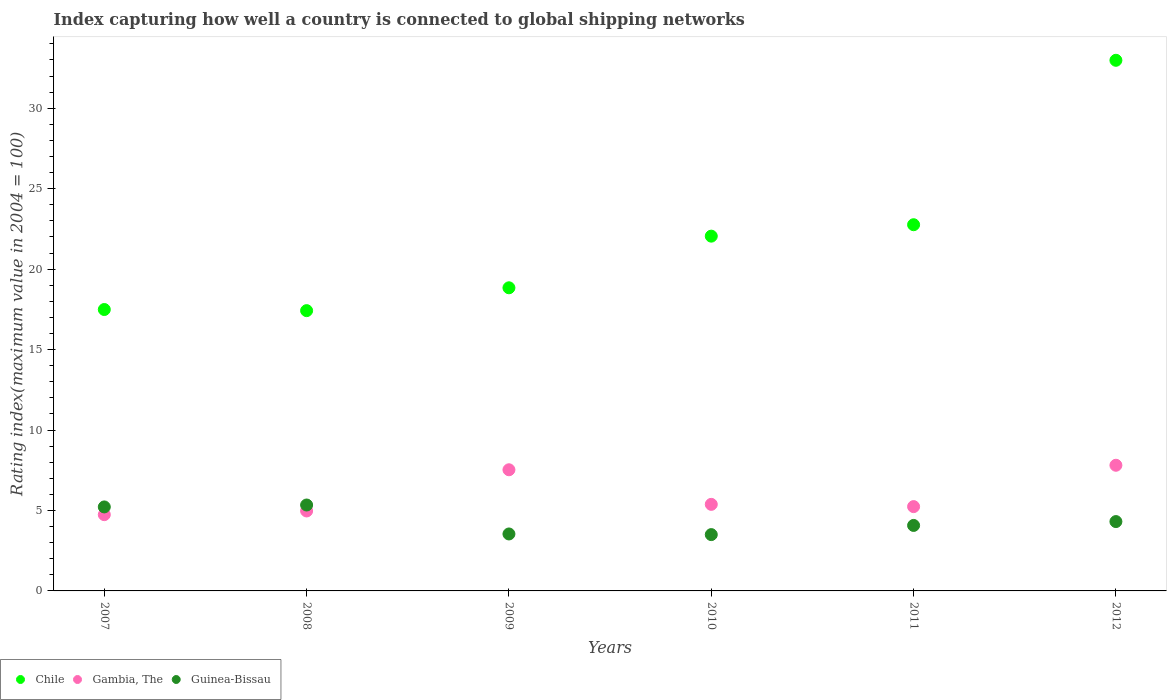Is the number of dotlines equal to the number of legend labels?
Your response must be concise. Yes. What is the rating index in Chile in 2007?
Offer a very short reply. 17.49. Across all years, what is the maximum rating index in Guinea-Bissau?
Your answer should be compact. 5.34. Across all years, what is the minimum rating index in Chile?
Offer a very short reply. 17.42. In which year was the rating index in Gambia, The minimum?
Your answer should be very brief. 2007. What is the total rating index in Chile in the graph?
Your answer should be compact. 131.54. What is the difference between the rating index in Guinea-Bissau in 2007 and that in 2011?
Offer a very short reply. 1.15. What is the difference between the rating index in Guinea-Bissau in 2011 and the rating index in Chile in 2009?
Make the answer very short. -14.77. What is the average rating index in Gambia, The per year?
Ensure brevity in your answer.  5.95. In the year 2009, what is the difference between the rating index in Guinea-Bissau and rating index in Chile?
Provide a short and direct response. -15.3. In how many years, is the rating index in Chile greater than 16?
Provide a succinct answer. 6. What is the ratio of the rating index in Gambia, The in 2008 to that in 2011?
Make the answer very short. 0.95. Is the rating index in Gambia, The in 2007 less than that in 2009?
Offer a terse response. Yes. Is the difference between the rating index in Guinea-Bissau in 2009 and 2010 greater than the difference between the rating index in Chile in 2009 and 2010?
Your answer should be very brief. Yes. What is the difference between the highest and the second highest rating index in Gambia, The?
Offer a terse response. 0.28. What is the difference between the highest and the lowest rating index in Chile?
Give a very brief answer. 15.56. Is the sum of the rating index in Chile in 2007 and 2008 greater than the maximum rating index in Guinea-Bissau across all years?
Provide a short and direct response. Yes. Does the rating index in Chile monotonically increase over the years?
Your answer should be very brief. No. Is the rating index in Gambia, The strictly greater than the rating index in Guinea-Bissau over the years?
Provide a succinct answer. No. What is the difference between two consecutive major ticks on the Y-axis?
Ensure brevity in your answer.  5. Are the values on the major ticks of Y-axis written in scientific E-notation?
Keep it short and to the point. No. Where does the legend appear in the graph?
Ensure brevity in your answer.  Bottom left. What is the title of the graph?
Your response must be concise. Index capturing how well a country is connected to global shipping networks. What is the label or title of the X-axis?
Your answer should be very brief. Years. What is the label or title of the Y-axis?
Provide a short and direct response. Rating index(maximum value in 2004 = 100). What is the Rating index(maximum value in 2004 = 100) of Chile in 2007?
Your response must be concise. 17.49. What is the Rating index(maximum value in 2004 = 100) in Gambia, The in 2007?
Keep it short and to the point. 4.74. What is the Rating index(maximum value in 2004 = 100) of Guinea-Bissau in 2007?
Provide a succinct answer. 5.22. What is the Rating index(maximum value in 2004 = 100) in Chile in 2008?
Your answer should be very brief. 17.42. What is the Rating index(maximum value in 2004 = 100) in Gambia, The in 2008?
Your answer should be compact. 4.97. What is the Rating index(maximum value in 2004 = 100) in Guinea-Bissau in 2008?
Offer a very short reply. 5.34. What is the Rating index(maximum value in 2004 = 100) of Chile in 2009?
Offer a very short reply. 18.84. What is the Rating index(maximum value in 2004 = 100) of Gambia, The in 2009?
Offer a very short reply. 7.53. What is the Rating index(maximum value in 2004 = 100) in Guinea-Bissau in 2009?
Make the answer very short. 3.54. What is the Rating index(maximum value in 2004 = 100) in Chile in 2010?
Your answer should be very brief. 22.05. What is the Rating index(maximum value in 2004 = 100) of Gambia, The in 2010?
Your response must be concise. 5.38. What is the Rating index(maximum value in 2004 = 100) of Guinea-Bissau in 2010?
Keep it short and to the point. 3.5. What is the Rating index(maximum value in 2004 = 100) in Chile in 2011?
Your answer should be compact. 22.76. What is the Rating index(maximum value in 2004 = 100) of Gambia, The in 2011?
Make the answer very short. 5.24. What is the Rating index(maximum value in 2004 = 100) of Guinea-Bissau in 2011?
Ensure brevity in your answer.  4.07. What is the Rating index(maximum value in 2004 = 100) of Chile in 2012?
Provide a short and direct response. 32.98. What is the Rating index(maximum value in 2004 = 100) in Gambia, The in 2012?
Keep it short and to the point. 7.81. What is the Rating index(maximum value in 2004 = 100) in Guinea-Bissau in 2012?
Offer a very short reply. 4.31. Across all years, what is the maximum Rating index(maximum value in 2004 = 100) of Chile?
Give a very brief answer. 32.98. Across all years, what is the maximum Rating index(maximum value in 2004 = 100) in Gambia, The?
Your answer should be very brief. 7.81. Across all years, what is the maximum Rating index(maximum value in 2004 = 100) of Guinea-Bissau?
Provide a short and direct response. 5.34. Across all years, what is the minimum Rating index(maximum value in 2004 = 100) in Chile?
Give a very brief answer. 17.42. Across all years, what is the minimum Rating index(maximum value in 2004 = 100) in Gambia, The?
Provide a short and direct response. 4.74. Across all years, what is the minimum Rating index(maximum value in 2004 = 100) of Guinea-Bissau?
Give a very brief answer. 3.5. What is the total Rating index(maximum value in 2004 = 100) of Chile in the graph?
Your answer should be compact. 131.54. What is the total Rating index(maximum value in 2004 = 100) of Gambia, The in the graph?
Ensure brevity in your answer.  35.67. What is the total Rating index(maximum value in 2004 = 100) in Guinea-Bissau in the graph?
Ensure brevity in your answer.  25.98. What is the difference between the Rating index(maximum value in 2004 = 100) in Chile in 2007 and that in 2008?
Your response must be concise. 0.07. What is the difference between the Rating index(maximum value in 2004 = 100) of Gambia, The in 2007 and that in 2008?
Keep it short and to the point. -0.23. What is the difference between the Rating index(maximum value in 2004 = 100) of Guinea-Bissau in 2007 and that in 2008?
Offer a terse response. -0.12. What is the difference between the Rating index(maximum value in 2004 = 100) of Chile in 2007 and that in 2009?
Provide a succinct answer. -1.35. What is the difference between the Rating index(maximum value in 2004 = 100) in Gambia, The in 2007 and that in 2009?
Offer a very short reply. -2.79. What is the difference between the Rating index(maximum value in 2004 = 100) in Guinea-Bissau in 2007 and that in 2009?
Offer a very short reply. 1.68. What is the difference between the Rating index(maximum value in 2004 = 100) in Chile in 2007 and that in 2010?
Your answer should be compact. -4.56. What is the difference between the Rating index(maximum value in 2004 = 100) in Gambia, The in 2007 and that in 2010?
Keep it short and to the point. -0.64. What is the difference between the Rating index(maximum value in 2004 = 100) in Guinea-Bissau in 2007 and that in 2010?
Your response must be concise. 1.72. What is the difference between the Rating index(maximum value in 2004 = 100) of Chile in 2007 and that in 2011?
Your answer should be very brief. -5.27. What is the difference between the Rating index(maximum value in 2004 = 100) in Guinea-Bissau in 2007 and that in 2011?
Provide a short and direct response. 1.15. What is the difference between the Rating index(maximum value in 2004 = 100) of Chile in 2007 and that in 2012?
Give a very brief answer. -15.49. What is the difference between the Rating index(maximum value in 2004 = 100) of Gambia, The in 2007 and that in 2012?
Offer a terse response. -3.07. What is the difference between the Rating index(maximum value in 2004 = 100) in Guinea-Bissau in 2007 and that in 2012?
Provide a short and direct response. 0.91. What is the difference between the Rating index(maximum value in 2004 = 100) of Chile in 2008 and that in 2009?
Your answer should be compact. -1.42. What is the difference between the Rating index(maximum value in 2004 = 100) of Gambia, The in 2008 and that in 2009?
Your answer should be compact. -2.56. What is the difference between the Rating index(maximum value in 2004 = 100) in Guinea-Bissau in 2008 and that in 2009?
Offer a very short reply. 1.8. What is the difference between the Rating index(maximum value in 2004 = 100) in Chile in 2008 and that in 2010?
Ensure brevity in your answer.  -4.63. What is the difference between the Rating index(maximum value in 2004 = 100) of Gambia, The in 2008 and that in 2010?
Your answer should be compact. -0.41. What is the difference between the Rating index(maximum value in 2004 = 100) of Guinea-Bissau in 2008 and that in 2010?
Keep it short and to the point. 1.84. What is the difference between the Rating index(maximum value in 2004 = 100) of Chile in 2008 and that in 2011?
Offer a very short reply. -5.34. What is the difference between the Rating index(maximum value in 2004 = 100) of Gambia, The in 2008 and that in 2011?
Offer a terse response. -0.27. What is the difference between the Rating index(maximum value in 2004 = 100) of Guinea-Bissau in 2008 and that in 2011?
Provide a short and direct response. 1.27. What is the difference between the Rating index(maximum value in 2004 = 100) in Chile in 2008 and that in 2012?
Provide a succinct answer. -15.56. What is the difference between the Rating index(maximum value in 2004 = 100) in Gambia, The in 2008 and that in 2012?
Give a very brief answer. -2.84. What is the difference between the Rating index(maximum value in 2004 = 100) in Guinea-Bissau in 2008 and that in 2012?
Your answer should be compact. 1.03. What is the difference between the Rating index(maximum value in 2004 = 100) of Chile in 2009 and that in 2010?
Give a very brief answer. -3.21. What is the difference between the Rating index(maximum value in 2004 = 100) of Gambia, The in 2009 and that in 2010?
Your answer should be compact. 2.15. What is the difference between the Rating index(maximum value in 2004 = 100) of Chile in 2009 and that in 2011?
Your response must be concise. -3.92. What is the difference between the Rating index(maximum value in 2004 = 100) of Gambia, The in 2009 and that in 2011?
Keep it short and to the point. 2.29. What is the difference between the Rating index(maximum value in 2004 = 100) in Guinea-Bissau in 2009 and that in 2011?
Keep it short and to the point. -0.53. What is the difference between the Rating index(maximum value in 2004 = 100) in Chile in 2009 and that in 2012?
Give a very brief answer. -14.14. What is the difference between the Rating index(maximum value in 2004 = 100) in Gambia, The in 2009 and that in 2012?
Offer a very short reply. -0.28. What is the difference between the Rating index(maximum value in 2004 = 100) in Guinea-Bissau in 2009 and that in 2012?
Give a very brief answer. -0.77. What is the difference between the Rating index(maximum value in 2004 = 100) of Chile in 2010 and that in 2011?
Your response must be concise. -0.71. What is the difference between the Rating index(maximum value in 2004 = 100) in Gambia, The in 2010 and that in 2011?
Your response must be concise. 0.14. What is the difference between the Rating index(maximum value in 2004 = 100) of Guinea-Bissau in 2010 and that in 2011?
Offer a very short reply. -0.57. What is the difference between the Rating index(maximum value in 2004 = 100) in Chile in 2010 and that in 2012?
Offer a very short reply. -10.93. What is the difference between the Rating index(maximum value in 2004 = 100) in Gambia, The in 2010 and that in 2012?
Your answer should be compact. -2.43. What is the difference between the Rating index(maximum value in 2004 = 100) of Guinea-Bissau in 2010 and that in 2012?
Your answer should be very brief. -0.81. What is the difference between the Rating index(maximum value in 2004 = 100) of Chile in 2011 and that in 2012?
Keep it short and to the point. -10.22. What is the difference between the Rating index(maximum value in 2004 = 100) of Gambia, The in 2011 and that in 2012?
Offer a very short reply. -2.57. What is the difference between the Rating index(maximum value in 2004 = 100) of Guinea-Bissau in 2011 and that in 2012?
Offer a very short reply. -0.24. What is the difference between the Rating index(maximum value in 2004 = 100) in Chile in 2007 and the Rating index(maximum value in 2004 = 100) in Gambia, The in 2008?
Ensure brevity in your answer.  12.52. What is the difference between the Rating index(maximum value in 2004 = 100) of Chile in 2007 and the Rating index(maximum value in 2004 = 100) of Guinea-Bissau in 2008?
Your answer should be very brief. 12.15. What is the difference between the Rating index(maximum value in 2004 = 100) of Chile in 2007 and the Rating index(maximum value in 2004 = 100) of Gambia, The in 2009?
Offer a very short reply. 9.96. What is the difference between the Rating index(maximum value in 2004 = 100) in Chile in 2007 and the Rating index(maximum value in 2004 = 100) in Guinea-Bissau in 2009?
Offer a very short reply. 13.95. What is the difference between the Rating index(maximum value in 2004 = 100) in Gambia, The in 2007 and the Rating index(maximum value in 2004 = 100) in Guinea-Bissau in 2009?
Offer a terse response. 1.2. What is the difference between the Rating index(maximum value in 2004 = 100) of Chile in 2007 and the Rating index(maximum value in 2004 = 100) of Gambia, The in 2010?
Keep it short and to the point. 12.11. What is the difference between the Rating index(maximum value in 2004 = 100) of Chile in 2007 and the Rating index(maximum value in 2004 = 100) of Guinea-Bissau in 2010?
Give a very brief answer. 13.99. What is the difference between the Rating index(maximum value in 2004 = 100) of Gambia, The in 2007 and the Rating index(maximum value in 2004 = 100) of Guinea-Bissau in 2010?
Your response must be concise. 1.24. What is the difference between the Rating index(maximum value in 2004 = 100) of Chile in 2007 and the Rating index(maximum value in 2004 = 100) of Gambia, The in 2011?
Ensure brevity in your answer.  12.25. What is the difference between the Rating index(maximum value in 2004 = 100) in Chile in 2007 and the Rating index(maximum value in 2004 = 100) in Guinea-Bissau in 2011?
Offer a very short reply. 13.42. What is the difference between the Rating index(maximum value in 2004 = 100) of Gambia, The in 2007 and the Rating index(maximum value in 2004 = 100) of Guinea-Bissau in 2011?
Give a very brief answer. 0.67. What is the difference between the Rating index(maximum value in 2004 = 100) in Chile in 2007 and the Rating index(maximum value in 2004 = 100) in Gambia, The in 2012?
Provide a succinct answer. 9.68. What is the difference between the Rating index(maximum value in 2004 = 100) in Chile in 2007 and the Rating index(maximum value in 2004 = 100) in Guinea-Bissau in 2012?
Your response must be concise. 13.18. What is the difference between the Rating index(maximum value in 2004 = 100) of Gambia, The in 2007 and the Rating index(maximum value in 2004 = 100) of Guinea-Bissau in 2012?
Offer a very short reply. 0.43. What is the difference between the Rating index(maximum value in 2004 = 100) in Chile in 2008 and the Rating index(maximum value in 2004 = 100) in Gambia, The in 2009?
Ensure brevity in your answer.  9.89. What is the difference between the Rating index(maximum value in 2004 = 100) of Chile in 2008 and the Rating index(maximum value in 2004 = 100) of Guinea-Bissau in 2009?
Provide a short and direct response. 13.88. What is the difference between the Rating index(maximum value in 2004 = 100) in Gambia, The in 2008 and the Rating index(maximum value in 2004 = 100) in Guinea-Bissau in 2009?
Provide a succinct answer. 1.43. What is the difference between the Rating index(maximum value in 2004 = 100) in Chile in 2008 and the Rating index(maximum value in 2004 = 100) in Gambia, The in 2010?
Keep it short and to the point. 12.04. What is the difference between the Rating index(maximum value in 2004 = 100) of Chile in 2008 and the Rating index(maximum value in 2004 = 100) of Guinea-Bissau in 2010?
Make the answer very short. 13.92. What is the difference between the Rating index(maximum value in 2004 = 100) of Gambia, The in 2008 and the Rating index(maximum value in 2004 = 100) of Guinea-Bissau in 2010?
Make the answer very short. 1.47. What is the difference between the Rating index(maximum value in 2004 = 100) of Chile in 2008 and the Rating index(maximum value in 2004 = 100) of Gambia, The in 2011?
Offer a very short reply. 12.18. What is the difference between the Rating index(maximum value in 2004 = 100) of Chile in 2008 and the Rating index(maximum value in 2004 = 100) of Guinea-Bissau in 2011?
Your response must be concise. 13.35. What is the difference between the Rating index(maximum value in 2004 = 100) of Gambia, The in 2008 and the Rating index(maximum value in 2004 = 100) of Guinea-Bissau in 2011?
Give a very brief answer. 0.9. What is the difference between the Rating index(maximum value in 2004 = 100) in Chile in 2008 and the Rating index(maximum value in 2004 = 100) in Gambia, The in 2012?
Offer a terse response. 9.61. What is the difference between the Rating index(maximum value in 2004 = 100) in Chile in 2008 and the Rating index(maximum value in 2004 = 100) in Guinea-Bissau in 2012?
Your answer should be compact. 13.11. What is the difference between the Rating index(maximum value in 2004 = 100) of Gambia, The in 2008 and the Rating index(maximum value in 2004 = 100) of Guinea-Bissau in 2012?
Your response must be concise. 0.66. What is the difference between the Rating index(maximum value in 2004 = 100) in Chile in 2009 and the Rating index(maximum value in 2004 = 100) in Gambia, The in 2010?
Make the answer very short. 13.46. What is the difference between the Rating index(maximum value in 2004 = 100) of Chile in 2009 and the Rating index(maximum value in 2004 = 100) of Guinea-Bissau in 2010?
Your response must be concise. 15.34. What is the difference between the Rating index(maximum value in 2004 = 100) of Gambia, The in 2009 and the Rating index(maximum value in 2004 = 100) of Guinea-Bissau in 2010?
Offer a terse response. 4.03. What is the difference between the Rating index(maximum value in 2004 = 100) of Chile in 2009 and the Rating index(maximum value in 2004 = 100) of Guinea-Bissau in 2011?
Your answer should be compact. 14.77. What is the difference between the Rating index(maximum value in 2004 = 100) in Gambia, The in 2009 and the Rating index(maximum value in 2004 = 100) in Guinea-Bissau in 2011?
Provide a succinct answer. 3.46. What is the difference between the Rating index(maximum value in 2004 = 100) of Chile in 2009 and the Rating index(maximum value in 2004 = 100) of Gambia, The in 2012?
Your answer should be very brief. 11.03. What is the difference between the Rating index(maximum value in 2004 = 100) in Chile in 2009 and the Rating index(maximum value in 2004 = 100) in Guinea-Bissau in 2012?
Make the answer very short. 14.53. What is the difference between the Rating index(maximum value in 2004 = 100) in Gambia, The in 2009 and the Rating index(maximum value in 2004 = 100) in Guinea-Bissau in 2012?
Make the answer very short. 3.22. What is the difference between the Rating index(maximum value in 2004 = 100) in Chile in 2010 and the Rating index(maximum value in 2004 = 100) in Gambia, The in 2011?
Keep it short and to the point. 16.81. What is the difference between the Rating index(maximum value in 2004 = 100) in Chile in 2010 and the Rating index(maximum value in 2004 = 100) in Guinea-Bissau in 2011?
Provide a succinct answer. 17.98. What is the difference between the Rating index(maximum value in 2004 = 100) of Gambia, The in 2010 and the Rating index(maximum value in 2004 = 100) of Guinea-Bissau in 2011?
Give a very brief answer. 1.31. What is the difference between the Rating index(maximum value in 2004 = 100) in Chile in 2010 and the Rating index(maximum value in 2004 = 100) in Gambia, The in 2012?
Make the answer very short. 14.24. What is the difference between the Rating index(maximum value in 2004 = 100) in Chile in 2010 and the Rating index(maximum value in 2004 = 100) in Guinea-Bissau in 2012?
Your response must be concise. 17.74. What is the difference between the Rating index(maximum value in 2004 = 100) in Gambia, The in 2010 and the Rating index(maximum value in 2004 = 100) in Guinea-Bissau in 2012?
Make the answer very short. 1.07. What is the difference between the Rating index(maximum value in 2004 = 100) in Chile in 2011 and the Rating index(maximum value in 2004 = 100) in Gambia, The in 2012?
Give a very brief answer. 14.95. What is the difference between the Rating index(maximum value in 2004 = 100) of Chile in 2011 and the Rating index(maximum value in 2004 = 100) of Guinea-Bissau in 2012?
Keep it short and to the point. 18.45. What is the difference between the Rating index(maximum value in 2004 = 100) in Gambia, The in 2011 and the Rating index(maximum value in 2004 = 100) in Guinea-Bissau in 2012?
Your response must be concise. 0.93. What is the average Rating index(maximum value in 2004 = 100) of Chile per year?
Your response must be concise. 21.92. What is the average Rating index(maximum value in 2004 = 100) in Gambia, The per year?
Your response must be concise. 5.95. What is the average Rating index(maximum value in 2004 = 100) in Guinea-Bissau per year?
Offer a very short reply. 4.33. In the year 2007, what is the difference between the Rating index(maximum value in 2004 = 100) of Chile and Rating index(maximum value in 2004 = 100) of Gambia, The?
Your answer should be compact. 12.75. In the year 2007, what is the difference between the Rating index(maximum value in 2004 = 100) in Chile and Rating index(maximum value in 2004 = 100) in Guinea-Bissau?
Offer a very short reply. 12.27. In the year 2007, what is the difference between the Rating index(maximum value in 2004 = 100) in Gambia, The and Rating index(maximum value in 2004 = 100) in Guinea-Bissau?
Your answer should be very brief. -0.48. In the year 2008, what is the difference between the Rating index(maximum value in 2004 = 100) in Chile and Rating index(maximum value in 2004 = 100) in Gambia, The?
Your answer should be very brief. 12.45. In the year 2008, what is the difference between the Rating index(maximum value in 2004 = 100) in Chile and Rating index(maximum value in 2004 = 100) in Guinea-Bissau?
Give a very brief answer. 12.08. In the year 2008, what is the difference between the Rating index(maximum value in 2004 = 100) in Gambia, The and Rating index(maximum value in 2004 = 100) in Guinea-Bissau?
Your response must be concise. -0.37. In the year 2009, what is the difference between the Rating index(maximum value in 2004 = 100) in Chile and Rating index(maximum value in 2004 = 100) in Gambia, The?
Give a very brief answer. 11.31. In the year 2009, what is the difference between the Rating index(maximum value in 2004 = 100) of Gambia, The and Rating index(maximum value in 2004 = 100) of Guinea-Bissau?
Your answer should be compact. 3.99. In the year 2010, what is the difference between the Rating index(maximum value in 2004 = 100) of Chile and Rating index(maximum value in 2004 = 100) of Gambia, The?
Make the answer very short. 16.67. In the year 2010, what is the difference between the Rating index(maximum value in 2004 = 100) of Chile and Rating index(maximum value in 2004 = 100) of Guinea-Bissau?
Offer a very short reply. 18.55. In the year 2010, what is the difference between the Rating index(maximum value in 2004 = 100) of Gambia, The and Rating index(maximum value in 2004 = 100) of Guinea-Bissau?
Give a very brief answer. 1.88. In the year 2011, what is the difference between the Rating index(maximum value in 2004 = 100) in Chile and Rating index(maximum value in 2004 = 100) in Gambia, The?
Offer a terse response. 17.52. In the year 2011, what is the difference between the Rating index(maximum value in 2004 = 100) in Chile and Rating index(maximum value in 2004 = 100) in Guinea-Bissau?
Your answer should be very brief. 18.69. In the year 2011, what is the difference between the Rating index(maximum value in 2004 = 100) in Gambia, The and Rating index(maximum value in 2004 = 100) in Guinea-Bissau?
Ensure brevity in your answer.  1.17. In the year 2012, what is the difference between the Rating index(maximum value in 2004 = 100) in Chile and Rating index(maximum value in 2004 = 100) in Gambia, The?
Give a very brief answer. 25.17. In the year 2012, what is the difference between the Rating index(maximum value in 2004 = 100) in Chile and Rating index(maximum value in 2004 = 100) in Guinea-Bissau?
Make the answer very short. 28.67. What is the ratio of the Rating index(maximum value in 2004 = 100) of Gambia, The in 2007 to that in 2008?
Offer a very short reply. 0.95. What is the ratio of the Rating index(maximum value in 2004 = 100) of Guinea-Bissau in 2007 to that in 2008?
Make the answer very short. 0.98. What is the ratio of the Rating index(maximum value in 2004 = 100) of Chile in 2007 to that in 2009?
Offer a very short reply. 0.93. What is the ratio of the Rating index(maximum value in 2004 = 100) in Gambia, The in 2007 to that in 2009?
Provide a succinct answer. 0.63. What is the ratio of the Rating index(maximum value in 2004 = 100) in Guinea-Bissau in 2007 to that in 2009?
Give a very brief answer. 1.47. What is the ratio of the Rating index(maximum value in 2004 = 100) in Chile in 2007 to that in 2010?
Ensure brevity in your answer.  0.79. What is the ratio of the Rating index(maximum value in 2004 = 100) in Gambia, The in 2007 to that in 2010?
Give a very brief answer. 0.88. What is the ratio of the Rating index(maximum value in 2004 = 100) of Guinea-Bissau in 2007 to that in 2010?
Offer a terse response. 1.49. What is the ratio of the Rating index(maximum value in 2004 = 100) of Chile in 2007 to that in 2011?
Provide a succinct answer. 0.77. What is the ratio of the Rating index(maximum value in 2004 = 100) in Gambia, The in 2007 to that in 2011?
Give a very brief answer. 0.9. What is the ratio of the Rating index(maximum value in 2004 = 100) of Guinea-Bissau in 2007 to that in 2011?
Your answer should be compact. 1.28. What is the ratio of the Rating index(maximum value in 2004 = 100) of Chile in 2007 to that in 2012?
Offer a very short reply. 0.53. What is the ratio of the Rating index(maximum value in 2004 = 100) of Gambia, The in 2007 to that in 2012?
Provide a succinct answer. 0.61. What is the ratio of the Rating index(maximum value in 2004 = 100) in Guinea-Bissau in 2007 to that in 2012?
Your answer should be compact. 1.21. What is the ratio of the Rating index(maximum value in 2004 = 100) in Chile in 2008 to that in 2009?
Your response must be concise. 0.92. What is the ratio of the Rating index(maximum value in 2004 = 100) of Gambia, The in 2008 to that in 2009?
Ensure brevity in your answer.  0.66. What is the ratio of the Rating index(maximum value in 2004 = 100) in Guinea-Bissau in 2008 to that in 2009?
Provide a short and direct response. 1.51. What is the ratio of the Rating index(maximum value in 2004 = 100) of Chile in 2008 to that in 2010?
Offer a very short reply. 0.79. What is the ratio of the Rating index(maximum value in 2004 = 100) in Gambia, The in 2008 to that in 2010?
Your answer should be compact. 0.92. What is the ratio of the Rating index(maximum value in 2004 = 100) of Guinea-Bissau in 2008 to that in 2010?
Provide a succinct answer. 1.53. What is the ratio of the Rating index(maximum value in 2004 = 100) in Chile in 2008 to that in 2011?
Provide a succinct answer. 0.77. What is the ratio of the Rating index(maximum value in 2004 = 100) in Gambia, The in 2008 to that in 2011?
Provide a short and direct response. 0.95. What is the ratio of the Rating index(maximum value in 2004 = 100) in Guinea-Bissau in 2008 to that in 2011?
Make the answer very short. 1.31. What is the ratio of the Rating index(maximum value in 2004 = 100) in Chile in 2008 to that in 2012?
Offer a terse response. 0.53. What is the ratio of the Rating index(maximum value in 2004 = 100) of Gambia, The in 2008 to that in 2012?
Make the answer very short. 0.64. What is the ratio of the Rating index(maximum value in 2004 = 100) in Guinea-Bissau in 2008 to that in 2012?
Provide a succinct answer. 1.24. What is the ratio of the Rating index(maximum value in 2004 = 100) of Chile in 2009 to that in 2010?
Your response must be concise. 0.85. What is the ratio of the Rating index(maximum value in 2004 = 100) in Gambia, The in 2009 to that in 2010?
Ensure brevity in your answer.  1.4. What is the ratio of the Rating index(maximum value in 2004 = 100) in Guinea-Bissau in 2009 to that in 2010?
Provide a succinct answer. 1.01. What is the ratio of the Rating index(maximum value in 2004 = 100) in Chile in 2009 to that in 2011?
Make the answer very short. 0.83. What is the ratio of the Rating index(maximum value in 2004 = 100) in Gambia, The in 2009 to that in 2011?
Make the answer very short. 1.44. What is the ratio of the Rating index(maximum value in 2004 = 100) of Guinea-Bissau in 2009 to that in 2011?
Offer a very short reply. 0.87. What is the ratio of the Rating index(maximum value in 2004 = 100) in Chile in 2009 to that in 2012?
Your response must be concise. 0.57. What is the ratio of the Rating index(maximum value in 2004 = 100) of Gambia, The in 2009 to that in 2012?
Keep it short and to the point. 0.96. What is the ratio of the Rating index(maximum value in 2004 = 100) of Guinea-Bissau in 2009 to that in 2012?
Keep it short and to the point. 0.82. What is the ratio of the Rating index(maximum value in 2004 = 100) in Chile in 2010 to that in 2011?
Offer a very short reply. 0.97. What is the ratio of the Rating index(maximum value in 2004 = 100) in Gambia, The in 2010 to that in 2011?
Give a very brief answer. 1.03. What is the ratio of the Rating index(maximum value in 2004 = 100) in Guinea-Bissau in 2010 to that in 2011?
Provide a succinct answer. 0.86. What is the ratio of the Rating index(maximum value in 2004 = 100) in Chile in 2010 to that in 2012?
Keep it short and to the point. 0.67. What is the ratio of the Rating index(maximum value in 2004 = 100) in Gambia, The in 2010 to that in 2012?
Your answer should be very brief. 0.69. What is the ratio of the Rating index(maximum value in 2004 = 100) of Guinea-Bissau in 2010 to that in 2012?
Your answer should be compact. 0.81. What is the ratio of the Rating index(maximum value in 2004 = 100) of Chile in 2011 to that in 2012?
Offer a terse response. 0.69. What is the ratio of the Rating index(maximum value in 2004 = 100) of Gambia, The in 2011 to that in 2012?
Your answer should be very brief. 0.67. What is the ratio of the Rating index(maximum value in 2004 = 100) in Guinea-Bissau in 2011 to that in 2012?
Your answer should be compact. 0.94. What is the difference between the highest and the second highest Rating index(maximum value in 2004 = 100) in Chile?
Your answer should be compact. 10.22. What is the difference between the highest and the second highest Rating index(maximum value in 2004 = 100) in Gambia, The?
Keep it short and to the point. 0.28. What is the difference between the highest and the second highest Rating index(maximum value in 2004 = 100) of Guinea-Bissau?
Give a very brief answer. 0.12. What is the difference between the highest and the lowest Rating index(maximum value in 2004 = 100) of Chile?
Your answer should be compact. 15.56. What is the difference between the highest and the lowest Rating index(maximum value in 2004 = 100) of Gambia, The?
Your answer should be very brief. 3.07. What is the difference between the highest and the lowest Rating index(maximum value in 2004 = 100) in Guinea-Bissau?
Your response must be concise. 1.84. 